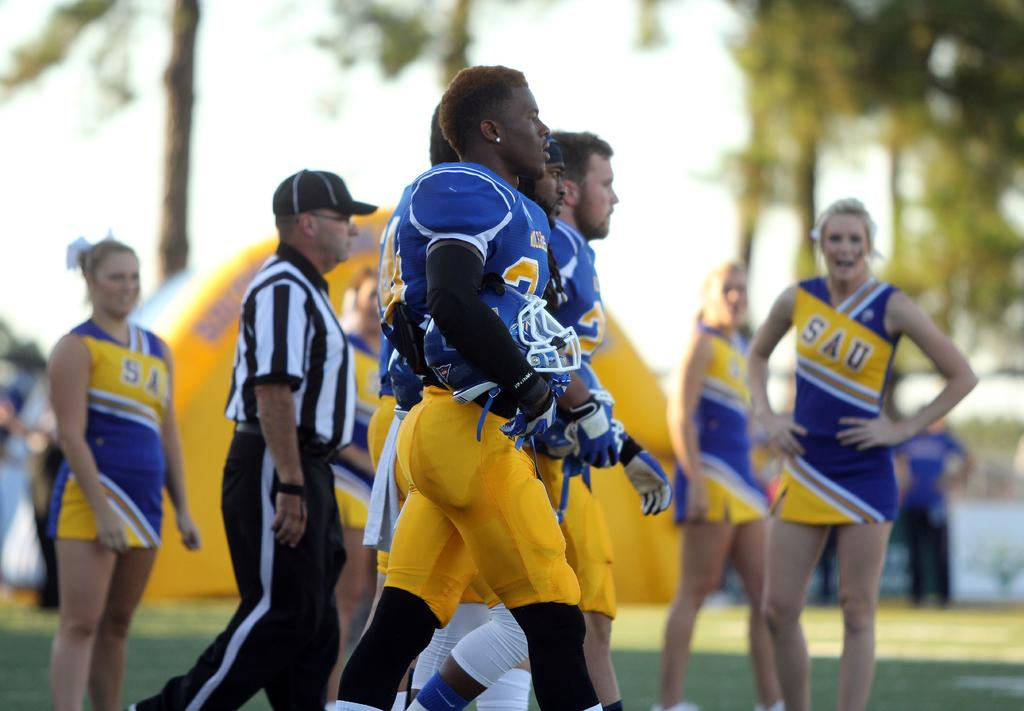Provide a one-sentence caption for the provided image. Cheerleaders in the distance watch as the SAU football team players march towards the field. 